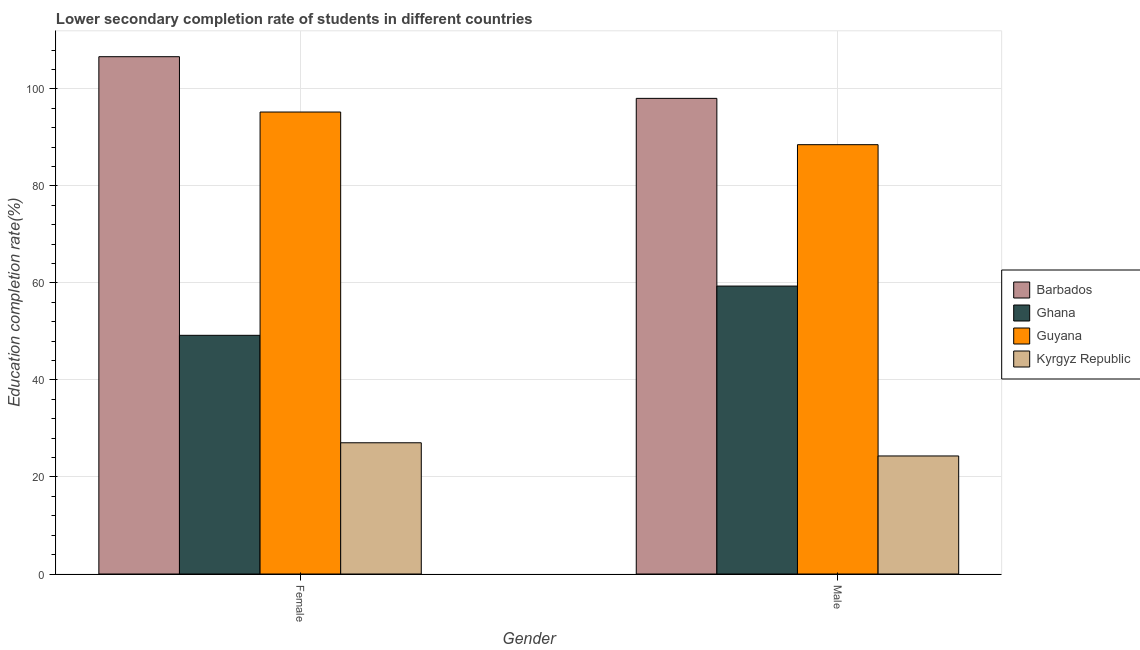Are the number of bars on each tick of the X-axis equal?
Keep it short and to the point. Yes. How many bars are there on the 2nd tick from the left?
Offer a terse response. 4. How many bars are there on the 2nd tick from the right?
Your answer should be very brief. 4. What is the education completion rate of male students in Ghana?
Keep it short and to the point. 59.36. Across all countries, what is the maximum education completion rate of male students?
Offer a terse response. 98.05. Across all countries, what is the minimum education completion rate of female students?
Provide a short and direct response. 27.05. In which country was the education completion rate of female students maximum?
Make the answer very short. Barbados. In which country was the education completion rate of female students minimum?
Your answer should be very brief. Kyrgyz Republic. What is the total education completion rate of male students in the graph?
Offer a terse response. 270.24. What is the difference between the education completion rate of male students in Guyana and that in Ghana?
Make the answer very short. 29.15. What is the difference between the education completion rate of female students in Guyana and the education completion rate of male students in Kyrgyz Republic?
Give a very brief answer. 70.9. What is the average education completion rate of female students per country?
Offer a terse response. 69.53. What is the difference between the education completion rate of female students and education completion rate of male students in Ghana?
Your answer should be compact. -10.15. What is the ratio of the education completion rate of male students in Kyrgyz Republic to that in Guyana?
Keep it short and to the point. 0.27. Is the education completion rate of female students in Ghana less than that in Guyana?
Offer a very short reply. Yes. In how many countries, is the education completion rate of female students greater than the average education completion rate of female students taken over all countries?
Your response must be concise. 2. How many bars are there?
Your response must be concise. 8. Are all the bars in the graph horizontal?
Ensure brevity in your answer.  No. Are the values on the major ticks of Y-axis written in scientific E-notation?
Your answer should be very brief. No. Does the graph contain any zero values?
Provide a succinct answer. No. What is the title of the graph?
Offer a terse response. Lower secondary completion rate of students in different countries. What is the label or title of the Y-axis?
Offer a terse response. Education completion rate(%). What is the Education completion rate(%) in Barbados in Female?
Ensure brevity in your answer.  106.64. What is the Education completion rate(%) in Ghana in Female?
Offer a terse response. 49.2. What is the Education completion rate(%) of Guyana in Female?
Ensure brevity in your answer.  95.24. What is the Education completion rate(%) of Kyrgyz Republic in Female?
Ensure brevity in your answer.  27.05. What is the Education completion rate(%) of Barbados in Male?
Offer a very short reply. 98.05. What is the Education completion rate(%) in Ghana in Male?
Your answer should be very brief. 59.36. What is the Education completion rate(%) in Guyana in Male?
Your answer should be very brief. 88.5. What is the Education completion rate(%) of Kyrgyz Republic in Male?
Your answer should be compact. 24.33. Across all Gender, what is the maximum Education completion rate(%) in Barbados?
Provide a short and direct response. 106.64. Across all Gender, what is the maximum Education completion rate(%) of Ghana?
Offer a very short reply. 59.36. Across all Gender, what is the maximum Education completion rate(%) of Guyana?
Offer a very short reply. 95.24. Across all Gender, what is the maximum Education completion rate(%) in Kyrgyz Republic?
Make the answer very short. 27.05. Across all Gender, what is the minimum Education completion rate(%) of Barbados?
Your response must be concise. 98.05. Across all Gender, what is the minimum Education completion rate(%) of Ghana?
Give a very brief answer. 49.2. Across all Gender, what is the minimum Education completion rate(%) of Guyana?
Your answer should be compact. 88.5. Across all Gender, what is the minimum Education completion rate(%) in Kyrgyz Republic?
Offer a terse response. 24.33. What is the total Education completion rate(%) in Barbados in the graph?
Your answer should be very brief. 204.69. What is the total Education completion rate(%) in Ghana in the graph?
Give a very brief answer. 108.56. What is the total Education completion rate(%) in Guyana in the graph?
Keep it short and to the point. 183.74. What is the total Education completion rate(%) in Kyrgyz Republic in the graph?
Your answer should be very brief. 51.39. What is the difference between the Education completion rate(%) in Barbados in Female and that in Male?
Keep it short and to the point. 8.59. What is the difference between the Education completion rate(%) in Ghana in Female and that in Male?
Your response must be concise. -10.15. What is the difference between the Education completion rate(%) in Guyana in Female and that in Male?
Your answer should be compact. 6.73. What is the difference between the Education completion rate(%) of Kyrgyz Republic in Female and that in Male?
Offer a terse response. 2.72. What is the difference between the Education completion rate(%) of Barbados in Female and the Education completion rate(%) of Ghana in Male?
Offer a very short reply. 47.28. What is the difference between the Education completion rate(%) of Barbados in Female and the Education completion rate(%) of Guyana in Male?
Make the answer very short. 18.14. What is the difference between the Education completion rate(%) in Barbados in Female and the Education completion rate(%) in Kyrgyz Republic in Male?
Offer a terse response. 82.31. What is the difference between the Education completion rate(%) in Ghana in Female and the Education completion rate(%) in Guyana in Male?
Offer a terse response. -39.3. What is the difference between the Education completion rate(%) in Ghana in Female and the Education completion rate(%) in Kyrgyz Republic in Male?
Offer a very short reply. 24.87. What is the difference between the Education completion rate(%) in Guyana in Female and the Education completion rate(%) in Kyrgyz Republic in Male?
Make the answer very short. 70.9. What is the average Education completion rate(%) of Barbados per Gender?
Provide a succinct answer. 102.35. What is the average Education completion rate(%) of Ghana per Gender?
Make the answer very short. 54.28. What is the average Education completion rate(%) of Guyana per Gender?
Ensure brevity in your answer.  91.87. What is the average Education completion rate(%) in Kyrgyz Republic per Gender?
Ensure brevity in your answer.  25.69. What is the difference between the Education completion rate(%) in Barbados and Education completion rate(%) in Ghana in Female?
Ensure brevity in your answer.  57.44. What is the difference between the Education completion rate(%) in Barbados and Education completion rate(%) in Guyana in Female?
Offer a terse response. 11.41. What is the difference between the Education completion rate(%) of Barbados and Education completion rate(%) of Kyrgyz Republic in Female?
Your answer should be compact. 79.59. What is the difference between the Education completion rate(%) in Ghana and Education completion rate(%) in Guyana in Female?
Make the answer very short. -46.03. What is the difference between the Education completion rate(%) of Ghana and Education completion rate(%) of Kyrgyz Republic in Female?
Your answer should be compact. 22.15. What is the difference between the Education completion rate(%) of Guyana and Education completion rate(%) of Kyrgyz Republic in Female?
Offer a terse response. 68.18. What is the difference between the Education completion rate(%) in Barbados and Education completion rate(%) in Ghana in Male?
Provide a short and direct response. 38.69. What is the difference between the Education completion rate(%) of Barbados and Education completion rate(%) of Guyana in Male?
Your answer should be compact. 9.55. What is the difference between the Education completion rate(%) of Barbados and Education completion rate(%) of Kyrgyz Republic in Male?
Your answer should be compact. 73.72. What is the difference between the Education completion rate(%) of Ghana and Education completion rate(%) of Guyana in Male?
Provide a short and direct response. -29.15. What is the difference between the Education completion rate(%) of Ghana and Education completion rate(%) of Kyrgyz Republic in Male?
Your answer should be very brief. 35.02. What is the difference between the Education completion rate(%) in Guyana and Education completion rate(%) in Kyrgyz Republic in Male?
Ensure brevity in your answer.  64.17. What is the ratio of the Education completion rate(%) in Barbados in Female to that in Male?
Provide a succinct answer. 1.09. What is the ratio of the Education completion rate(%) of Ghana in Female to that in Male?
Ensure brevity in your answer.  0.83. What is the ratio of the Education completion rate(%) of Guyana in Female to that in Male?
Give a very brief answer. 1.08. What is the ratio of the Education completion rate(%) of Kyrgyz Republic in Female to that in Male?
Make the answer very short. 1.11. What is the difference between the highest and the second highest Education completion rate(%) of Barbados?
Your response must be concise. 8.59. What is the difference between the highest and the second highest Education completion rate(%) in Ghana?
Provide a succinct answer. 10.15. What is the difference between the highest and the second highest Education completion rate(%) in Guyana?
Your answer should be very brief. 6.73. What is the difference between the highest and the second highest Education completion rate(%) of Kyrgyz Republic?
Provide a succinct answer. 2.72. What is the difference between the highest and the lowest Education completion rate(%) in Barbados?
Offer a terse response. 8.59. What is the difference between the highest and the lowest Education completion rate(%) of Ghana?
Your response must be concise. 10.15. What is the difference between the highest and the lowest Education completion rate(%) of Guyana?
Provide a succinct answer. 6.73. What is the difference between the highest and the lowest Education completion rate(%) of Kyrgyz Republic?
Give a very brief answer. 2.72. 